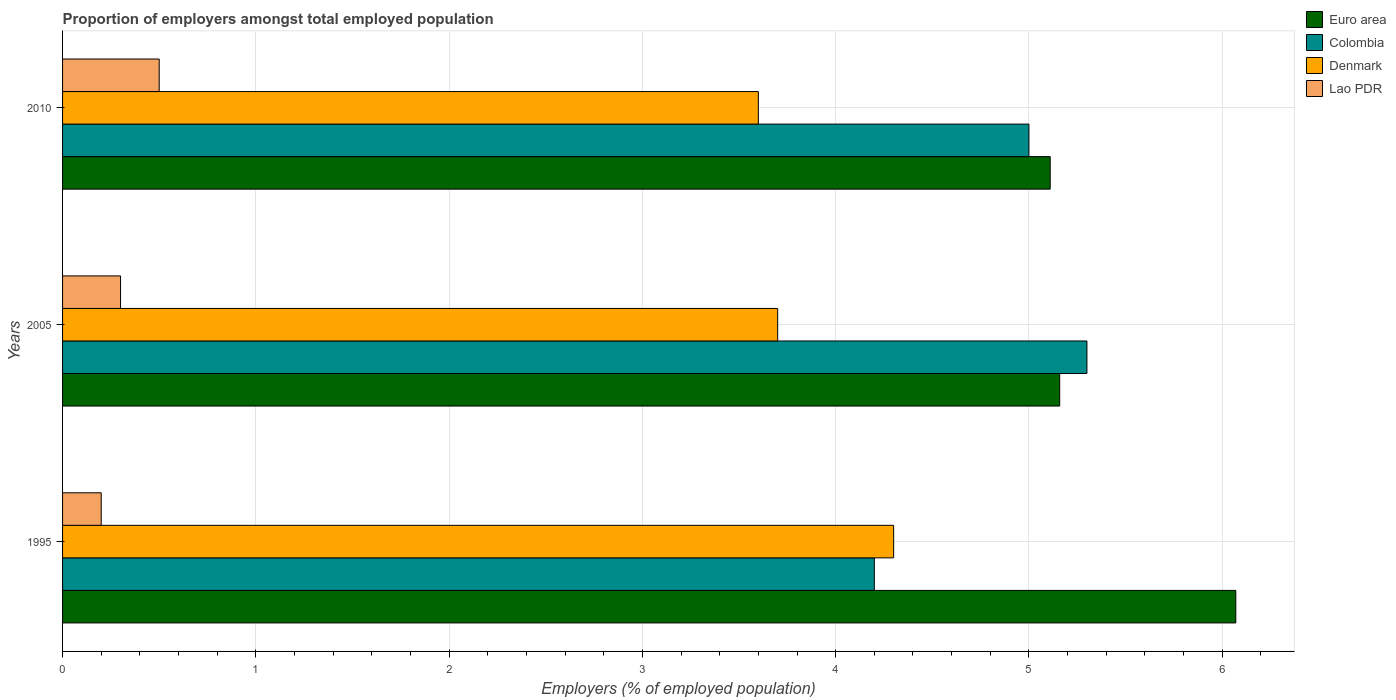How many different coloured bars are there?
Provide a succinct answer. 4. How many groups of bars are there?
Your answer should be compact. 3. Are the number of bars per tick equal to the number of legend labels?
Your answer should be compact. Yes. Are the number of bars on each tick of the Y-axis equal?
Your response must be concise. Yes. How many bars are there on the 3rd tick from the top?
Offer a terse response. 4. What is the label of the 2nd group of bars from the top?
Your answer should be very brief. 2005. What is the proportion of employers in Denmark in 1995?
Your answer should be very brief. 4.3. Across all years, what is the maximum proportion of employers in Denmark?
Your answer should be very brief. 4.3. Across all years, what is the minimum proportion of employers in Colombia?
Your response must be concise. 4.2. In which year was the proportion of employers in Lao PDR maximum?
Ensure brevity in your answer.  2010. What is the total proportion of employers in Euro area in the graph?
Offer a very short reply. 16.34. What is the difference between the proportion of employers in Colombia in 2005 and that in 2010?
Your answer should be very brief. 0.3. What is the difference between the proportion of employers in Colombia in 2010 and the proportion of employers in Euro area in 1995?
Give a very brief answer. -1.07. What is the average proportion of employers in Euro area per year?
Keep it short and to the point. 5.45. In the year 2010, what is the difference between the proportion of employers in Colombia and proportion of employers in Euro area?
Your response must be concise. -0.11. In how many years, is the proportion of employers in Denmark greater than 3.2 %?
Keep it short and to the point. 3. What is the ratio of the proportion of employers in Colombia in 1995 to that in 2010?
Keep it short and to the point. 0.84. What is the difference between the highest and the second highest proportion of employers in Euro area?
Make the answer very short. 0.91. What is the difference between the highest and the lowest proportion of employers in Denmark?
Make the answer very short. 0.7. Is it the case that in every year, the sum of the proportion of employers in Euro area and proportion of employers in Lao PDR is greater than the sum of proportion of employers in Denmark and proportion of employers in Colombia?
Keep it short and to the point. No. What does the 4th bar from the top in 2010 represents?
Make the answer very short. Euro area. How many bars are there?
Make the answer very short. 12. Are all the bars in the graph horizontal?
Your answer should be compact. Yes. How many years are there in the graph?
Make the answer very short. 3. Does the graph contain any zero values?
Provide a succinct answer. No. Does the graph contain grids?
Keep it short and to the point. Yes. Where does the legend appear in the graph?
Offer a terse response. Top right. How many legend labels are there?
Provide a succinct answer. 4. What is the title of the graph?
Offer a terse response. Proportion of employers amongst total employed population. Does "Cote d'Ivoire" appear as one of the legend labels in the graph?
Give a very brief answer. No. What is the label or title of the X-axis?
Give a very brief answer. Employers (% of employed population). What is the Employers (% of employed population) of Euro area in 1995?
Your answer should be compact. 6.07. What is the Employers (% of employed population) of Colombia in 1995?
Make the answer very short. 4.2. What is the Employers (% of employed population) in Denmark in 1995?
Your answer should be very brief. 4.3. What is the Employers (% of employed population) of Lao PDR in 1995?
Offer a very short reply. 0.2. What is the Employers (% of employed population) in Euro area in 2005?
Give a very brief answer. 5.16. What is the Employers (% of employed population) in Colombia in 2005?
Your answer should be compact. 5.3. What is the Employers (% of employed population) in Denmark in 2005?
Your response must be concise. 3.7. What is the Employers (% of employed population) in Lao PDR in 2005?
Give a very brief answer. 0.3. What is the Employers (% of employed population) of Euro area in 2010?
Your answer should be compact. 5.11. What is the Employers (% of employed population) of Denmark in 2010?
Provide a succinct answer. 3.6. Across all years, what is the maximum Employers (% of employed population) of Euro area?
Offer a terse response. 6.07. Across all years, what is the maximum Employers (% of employed population) in Colombia?
Offer a very short reply. 5.3. Across all years, what is the maximum Employers (% of employed population) of Denmark?
Ensure brevity in your answer.  4.3. Across all years, what is the minimum Employers (% of employed population) of Euro area?
Your answer should be compact. 5.11. Across all years, what is the minimum Employers (% of employed population) of Colombia?
Ensure brevity in your answer.  4.2. Across all years, what is the minimum Employers (% of employed population) in Denmark?
Offer a terse response. 3.6. Across all years, what is the minimum Employers (% of employed population) of Lao PDR?
Your response must be concise. 0.2. What is the total Employers (% of employed population) of Euro area in the graph?
Your response must be concise. 16.34. What is the total Employers (% of employed population) in Colombia in the graph?
Keep it short and to the point. 14.5. What is the difference between the Employers (% of employed population) in Euro area in 1995 and that in 2005?
Make the answer very short. 0.91. What is the difference between the Employers (% of employed population) of Denmark in 1995 and that in 2005?
Offer a very short reply. 0.6. What is the difference between the Employers (% of employed population) of Lao PDR in 1995 and that in 2005?
Offer a terse response. -0.1. What is the difference between the Employers (% of employed population) in Euro area in 1995 and that in 2010?
Ensure brevity in your answer.  0.96. What is the difference between the Employers (% of employed population) in Colombia in 1995 and that in 2010?
Provide a short and direct response. -0.8. What is the difference between the Employers (% of employed population) of Lao PDR in 1995 and that in 2010?
Offer a terse response. -0.3. What is the difference between the Employers (% of employed population) in Euro area in 2005 and that in 2010?
Offer a terse response. 0.05. What is the difference between the Employers (% of employed population) of Denmark in 2005 and that in 2010?
Offer a very short reply. 0.1. What is the difference between the Employers (% of employed population) in Lao PDR in 2005 and that in 2010?
Your answer should be very brief. -0.2. What is the difference between the Employers (% of employed population) in Euro area in 1995 and the Employers (% of employed population) in Colombia in 2005?
Provide a short and direct response. 0.77. What is the difference between the Employers (% of employed population) in Euro area in 1995 and the Employers (% of employed population) in Denmark in 2005?
Offer a very short reply. 2.37. What is the difference between the Employers (% of employed population) of Euro area in 1995 and the Employers (% of employed population) of Lao PDR in 2005?
Your response must be concise. 5.77. What is the difference between the Employers (% of employed population) in Colombia in 1995 and the Employers (% of employed population) in Denmark in 2005?
Give a very brief answer. 0.5. What is the difference between the Employers (% of employed population) of Euro area in 1995 and the Employers (% of employed population) of Colombia in 2010?
Provide a succinct answer. 1.07. What is the difference between the Employers (% of employed population) of Euro area in 1995 and the Employers (% of employed population) of Denmark in 2010?
Offer a terse response. 2.47. What is the difference between the Employers (% of employed population) in Euro area in 1995 and the Employers (% of employed population) in Lao PDR in 2010?
Your response must be concise. 5.57. What is the difference between the Employers (% of employed population) in Colombia in 1995 and the Employers (% of employed population) in Denmark in 2010?
Keep it short and to the point. 0.6. What is the difference between the Employers (% of employed population) of Denmark in 1995 and the Employers (% of employed population) of Lao PDR in 2010?
Provide a succinct answer. 3.8. What is the difference between the Employers (% of employed population) of Euro area in 2005 and the Employers (% of employed population) of Colombia in 2010?
Your response must be concise. 0.16. What is the difference between the Employers (% of employed population) of Euro area in 2005 and the Employers (% of employed population) of Denmark in 2010?
Your answer should be very brief. 1.56. What is the difference between the Employers (% of employed population) of Euro area in 2005 and the Employers (% of employed population) of Lao PDR in 2010?
Provide a succinct answer. 4.66. What is the difference between the Employers (% of employed population) of Colombia in 2005 and the Employers (% of employed population) of Denmark in 2010?
Offer a terse response. 1.7. What is the difference between the Employers (% of employed population) in Colombia in 2005 and the Employers (% of employed population) in Lao PDR in 2010?
Your answer should be very brief. 4.8. What is the average Employers (% of employed population) in Euro area per year?
Give a very brief answer. 5.45. What is the average Employers (% of employed population) of Colombia per year?
Keep it short and to the point. 4.83. What is the average Employers (% of employed population) in Denmark per year?
Ensure brevity in your answer.  3.87. What is the average Employers (% of employed population) in Lao PDR per year?
Keep it short and to the point. 0.33. In the year 1995, what is the difference between the Employers (% of employed population) of Euro area and Employers (% of employed population) of Colombia?
Ensure brevity in your answer.  1.87. In the year 1995, what is the difference between the Employers (% of employed population) of Euro area and Employers (% of employed population) of Denmark?
Offer a terse response. 1.77. In the year 1995, what is the difference between the Employers (% of employed population) of Euro area and Employers (% of employed population) of Lao PDR?
Your answer should be compact. 5.87. In the year 1995, what is the difference between the Employers (% of employed population) of Colombia and Employers (% of employed population) of Denmark?
Your answer should be compact. -0.1. In the year 2005, what is the difference between the Employers (% of employed population) in Euro area and Employers (% of employed population) in Colombia?
Provide a short and direct response. -0.14. In the year 2005, what is the difference between the Employers (% of employed population) in Euro area and Employers (% of employed population) in Denmark?
Ensure brevity in your answer.  1.46. In the year 2005, what is the difference between the Employers (% of employed population) of Euro area and Employers (% of employed population) of Lao PDR?
Offer a very short reply. 4.86. In the year 2005, what is the difference between the Employers (% of employed population) of Colombia and Employers (% of employed population) of Denmark?
Offer a terse response. 1.6. In the year 2005, what is the difference between the Employers (% of employed population) of Denmark and Employers (% of employed population) of Lao PDR?
Your answer should be very brief. 3.4. In the year 2010, what is the difference between the Employers (% of employed population) in Euro area and Employers (% of employed population) in Colombia?
Provide a short and direct response. 0.11. In the year 2010, what is the difference between the Employers (% of employed population) in Euro area and Employers (% of employed population) in Denmark?
Make the answer very short. 1.51. In the year 2010, what is the difference between the Employers (% of employed population) of Euro area and Employers (% of employed population) of Lao PDR?
Your answer should be very brief. 4.61. In the year 2010, what is the difference between the Employers (% of employed population) of Colombia and Employers (% of employed population) of Denmark?
Your answer should be compact. 1.4. What is the ratio of the Employers (% of employed population) of Euro area in 1995 to that in 2005?
Give a very brief answer. 1.18. What is the ratio of the Employers (% of employed population) of Colombia in 1995 to that in 2005?
Give a very brief answer. 0.79. What is the ratio of the Employers (% of employed population) in Denmark in 1995 to that in 2005?
Give a very brief answer. 1.16. What is the ratio of the Employers (% of employed population) in Euro area in 1995 to that in 2010?
Make the answer very short. 1.19. What is the ratio of the Employers (% of employed population) in Colombia in 1995 to that in 2010?
Give a very brief answer. 0.84. What is the ratio of the Employers (% of employed population) in Denmark in 1995 to that in 2010?
Ensure brevity in your answer.  1.19. What is the ratio of the Employers (% of employed population) of Lao PDR in 1995 to that in 2010?
Your answer should be compact. 0.4. What is the ratio of the Employers (% of employed population) of Euro area in 2005 to that in 2010?
Keep it short and to the point. 1.01. What is the ratio of the Employers (% of employed population) of Colombia in 2005 to that in 2010?
Give a very brief answer. 1.06. What is the ratio of the Employers (% of employed population) of Denmark in 2005 to that in 2010?
Ensure brevity in your answer.  1.03. What is the difference between the highest and the second highest Employers (% of employed population) of Euro area?
Provide a succinct answer. 0.91. What is the difference between the highest and the second highest Employers (% of employed population) in Colombia?
Provide a succinct answer. 0.3. What is the difference between the highest and the second highest Employers (% of employed population) in Denmark?
Provide a short and direct response. 0.6. What is the difference between the highest and the lowest Employers (% of employed population) of Euro area?
Your answer should be very brief. 0.96. What is the difference between the highest and the lowest Employers (% of employed population) in Colombia?
Keep it short and to the point. 1.1. What is the difference between the highest and the lowest Employers (% of employed population) of Denmark?
Offer a very short reply. 0.7. What is the difference between the highest and the lowest Employers (% of employed population) of Lao PDR?
Offer a terse response. 0.3. 